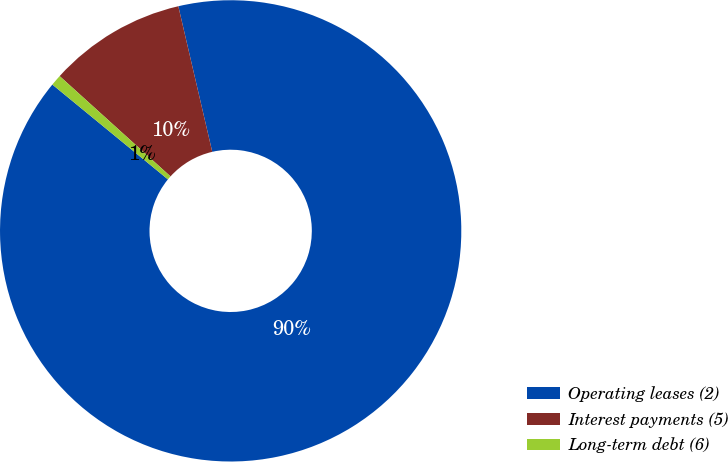Convert chart. <chart><loc_0><loc_0><loc_500><loc_500><pie_chart><fcel>Operating leases (2)<fcel>Interest payments (5)<fcel>Long-term debt (6)<nl><fcel>89.58%<fcel>9.65%<fcel>0.77%<nl></chart> 